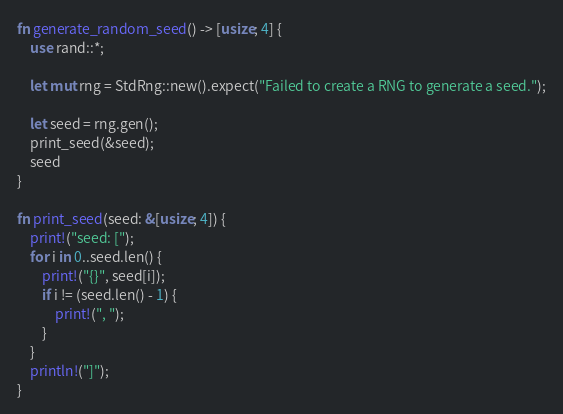<code> <loc_0><loc_0><loc_500><loc_500><_Rust_>
fn generate_random_seed() -> [usize; 4] {
    use rand::*;

    let mut rng = StdRng::new().expect("Failed to create a RNG to generate a seed.");

    let seed = rng.gen();
    print_seed(&seed);
    seed
}

fn print_seed(seed: &[usize; 4]) {
    print!("seed: [");
    for i in 0..seed.len() {
        print!("{}", seed[i]);
        if i != (seed.len() - 1) {
            print!(", ");
        }
    }
    println!("]");
}
</code> 